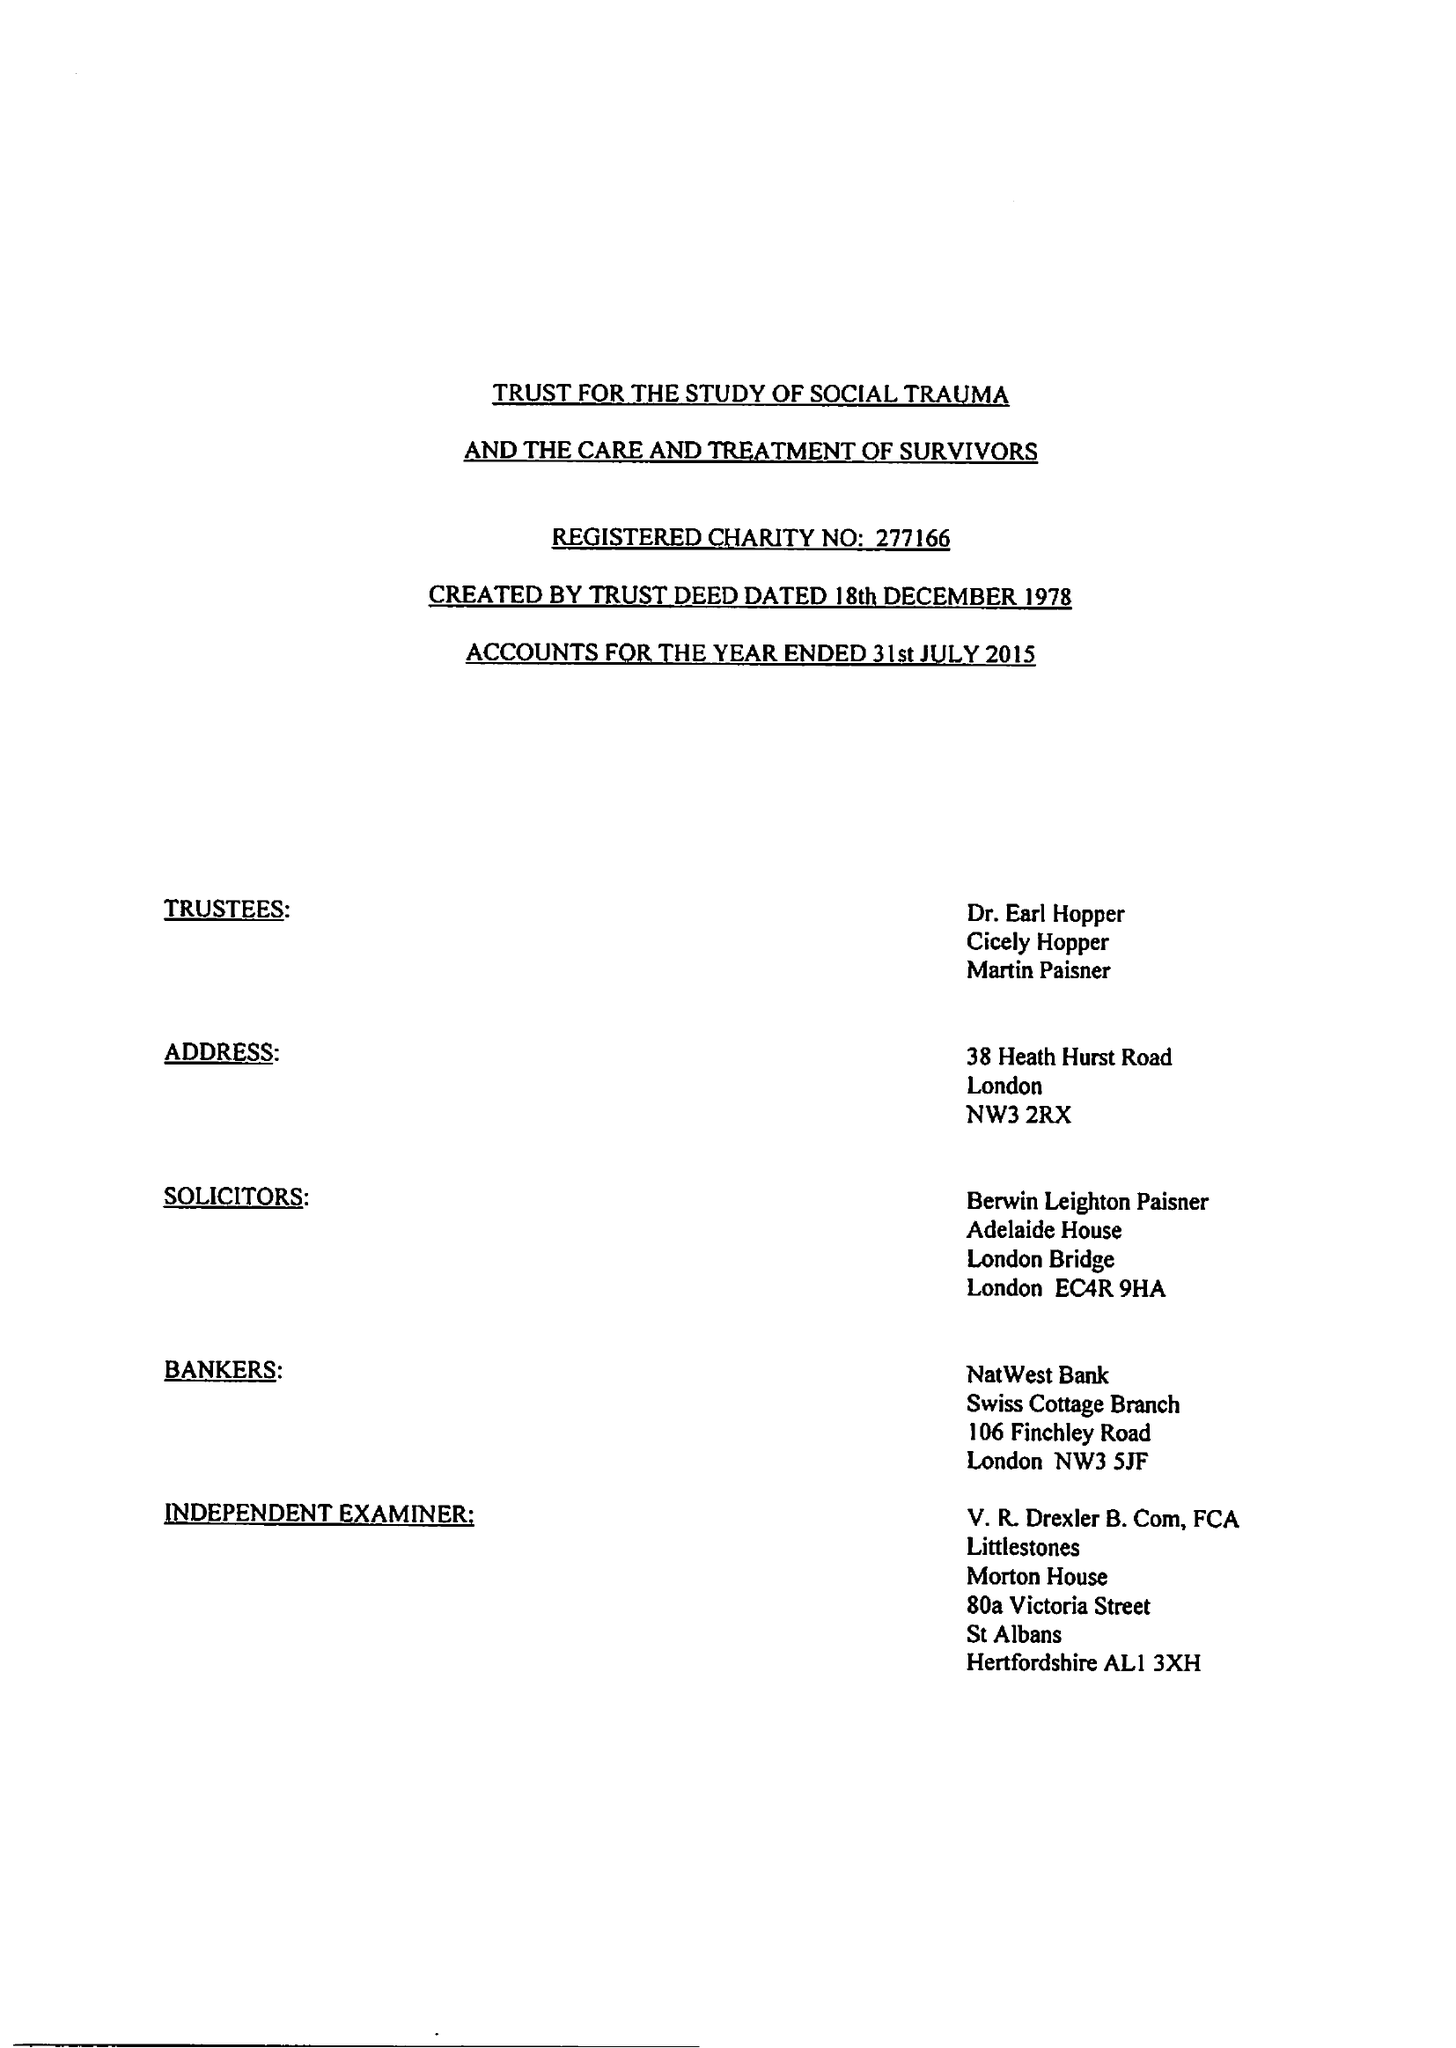What is the value for the income_annually_in_british_pounds?
Answer the question using a single word or phrase. 88480.00 